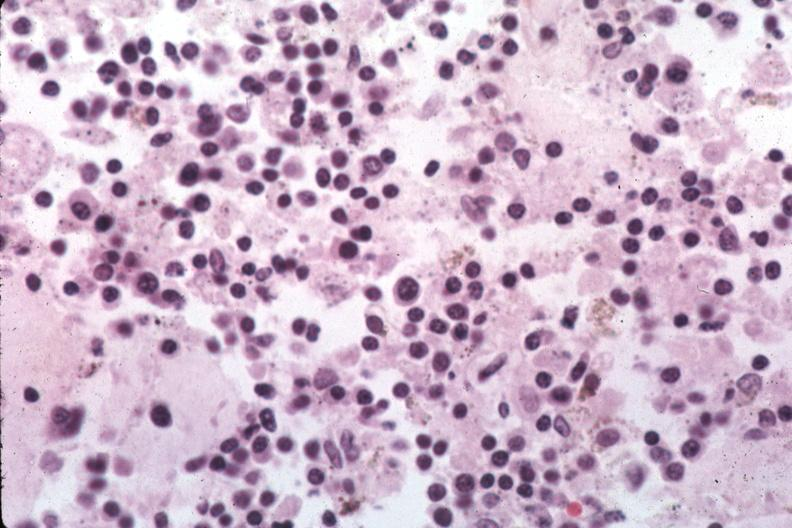what is present?
Answer the question using a single word or phrase. Histoplasmosis 